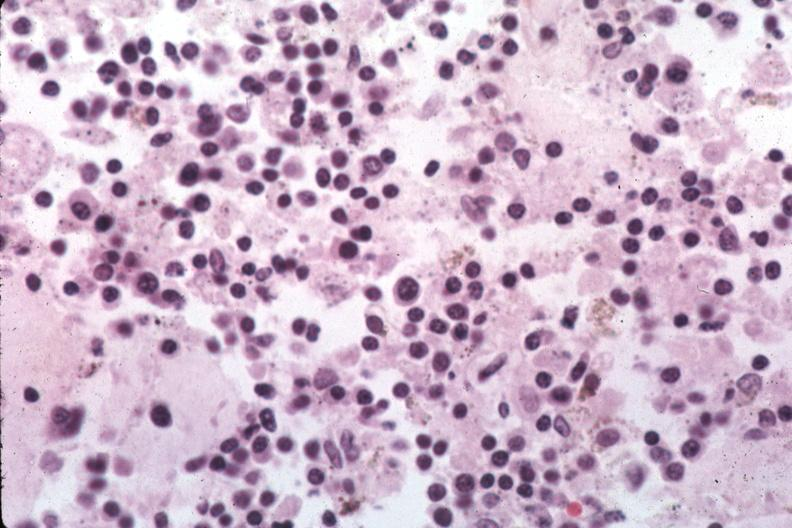what is present?
Answer the question using a single word or phrase. Histoplasmosis 